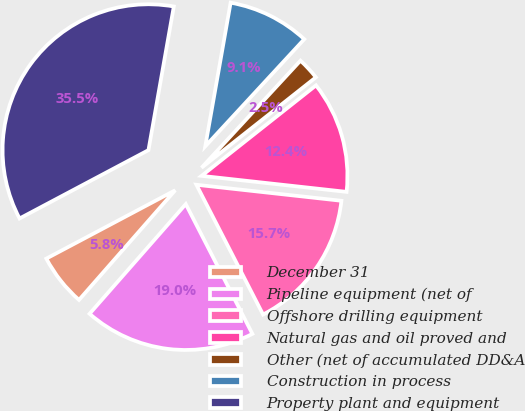<chart> <loc_0><loc_0><loc_500><loc_500><pie_chart><fcel>December 31<fcel>Pipeline equipment (net of<fcel>Offshore drilling equipment<fcel>Natural gas and oil proved and<fcel>Other (net of accumulated DD&A<fcel>Construction in process<fcel>Property plant and equipment<nl><fcel>5.78%<fcel>19.01%<fcel>15.7%<fcel>12.4%<fcel>2.48%<fcel>9.09%<fcel>35.54%<nl></chart> 